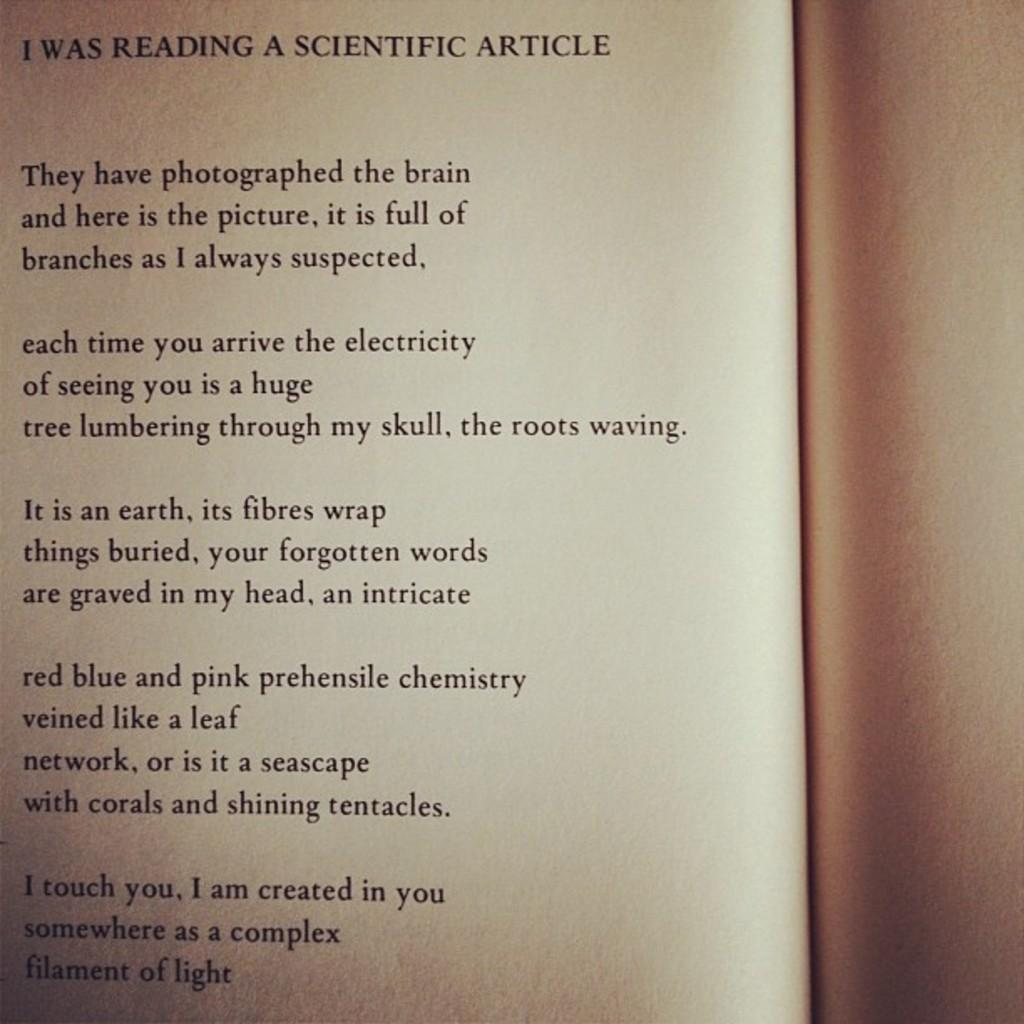<image>
Give a short and clear explanation of the subsequent image. The article starts with the sentence They have photographed the brain. 